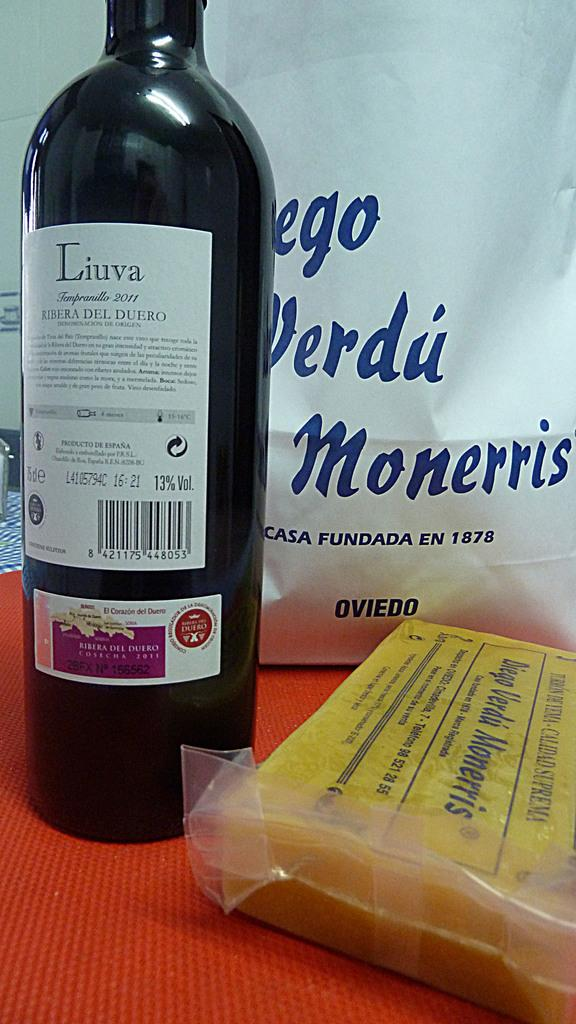<image>
Give a short and clear explanation of the subsequent image. A black bottle of wine with the label Liuva on the top is sitting next to a shrink wrapped item. 